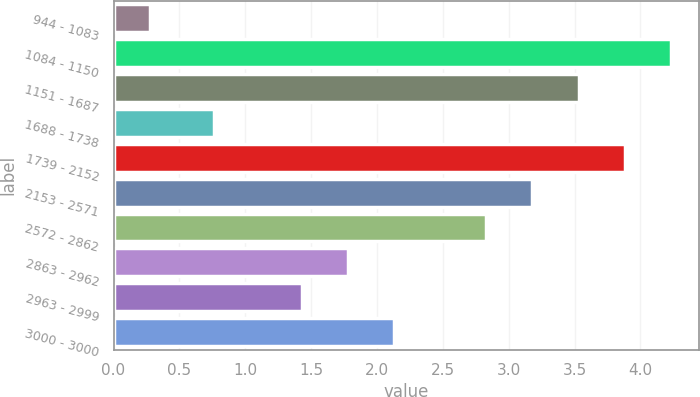<chart> <loc_0><loc_0><loc_500><loc_500><bar_chart><fcel>944 - 1083<fcel>1084 - 1150<fcel>1151 - 1687<fcel>1688 - 1738<fcel>1739 - 2152<fcel>2153 - 2571<fcel>2572 - 2862<fcel>2863 - 2962<fcel>2963 - 2999<fcel>3000 - 3000<nl><fcel>0.28<fcel>4.23<fcel>3.53<fcel>0.76<fcel>3.88<fcel>3.18<fcel>2.83<fcel>1.78<fcel>1.43<fcel>2.13<nl></chart> 